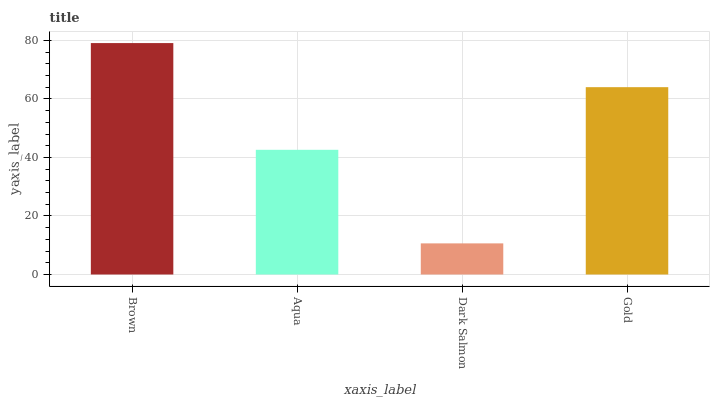Is Aqua the minimum?
Answer yes or no. No. Is Aqua the maximum?
Answer yes or no. No. Is Brown greater than Aqua?
Answer yes or no. Yes. Is Aqua less than Brown?
Answer yes or no. Yes. Is Aqua greater than Brown?
Answer yes or no. No. Is Brown less than Aqua?
Answer yes or no. No. Is Gold the high median?
Answer yes or no. Yes. Is Aqua the low median?
Answer yes or no. Yes. Is Dark Salmon the high median?
Answer yes or no. No. Is Dark Salmon the low median?
Answer yes or no. No. 